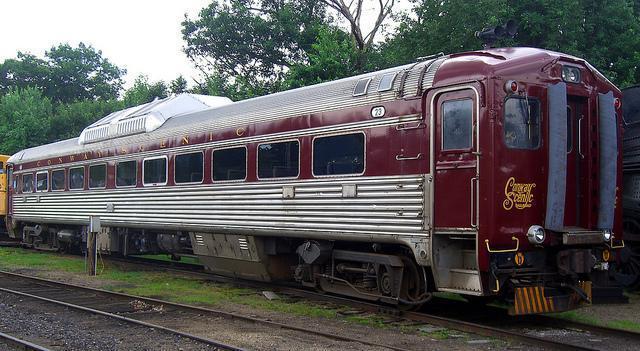How many white and green surfboards are in the image?
Give a very brief answer. 0. 